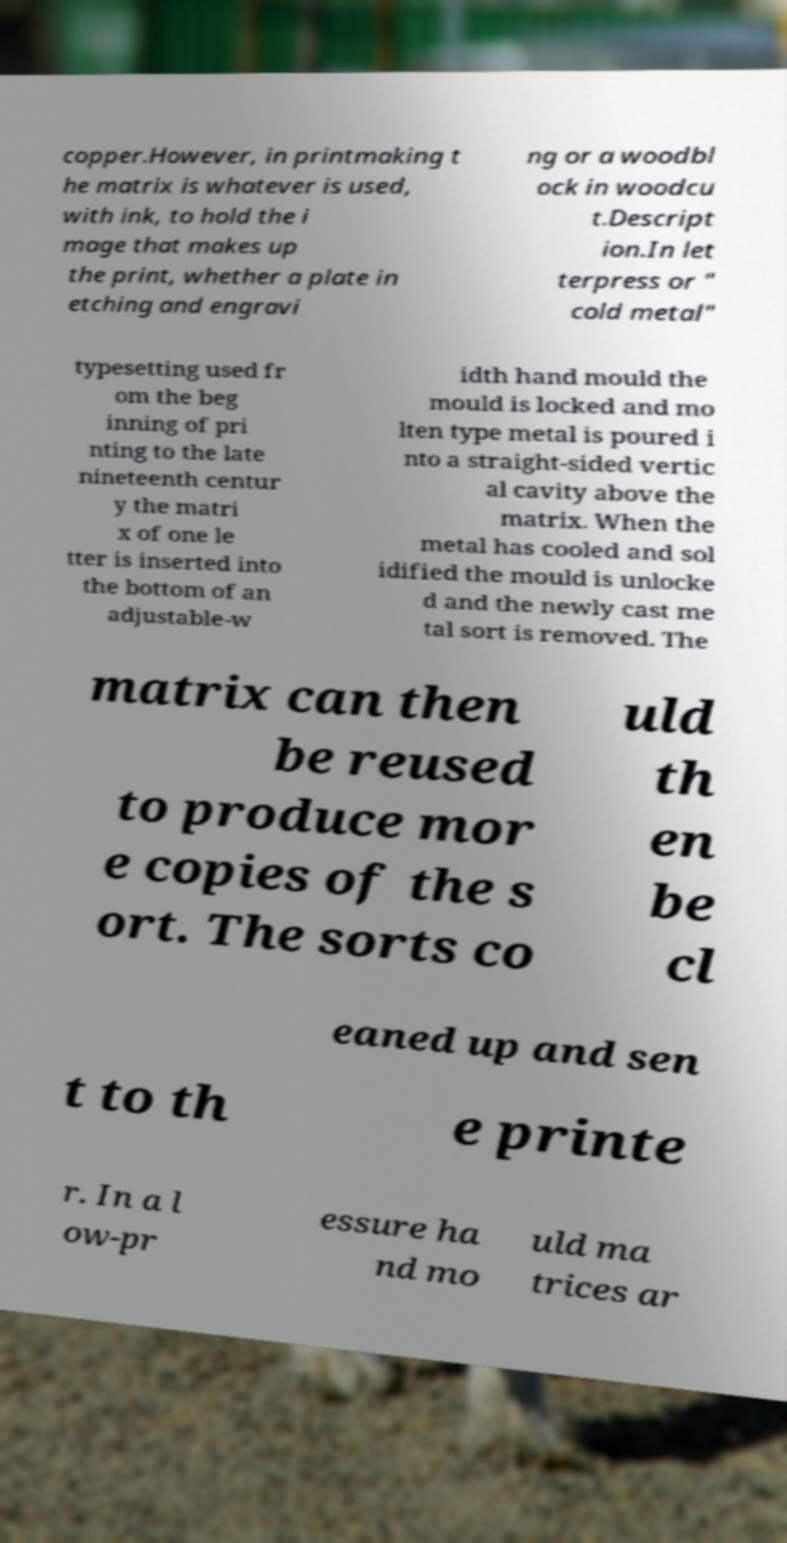Please identify and transcribe the text found in this image. copper.However, in printmaking t he matrix is whatever is used, with ink, to hold the i mage that makes up the print, whether a plate in etching and engravi ng or a woodbl ock in woodcu t.Descript ion.In let terpress or " cold metal" typesetting used fr om the beg inning of pri nting to the late nineteenth centur y the matri x of one le tter is inserted into the bottom of an adjustable-w idth hand mould the mould is locked and mo lten type metal is poured i nto a straight-sided vertic al cavity above the matrix. When the metal has cooled and sol idified the mould is unlocke d and the newly cast me tal sort is removed. The matrix can then be reused to produce mor e copies of the s ort. The sorts co uld th en be cl eaned up and sen t to th e printe r. In a l ow-pr essure ha nd mo uld ma trices ar 